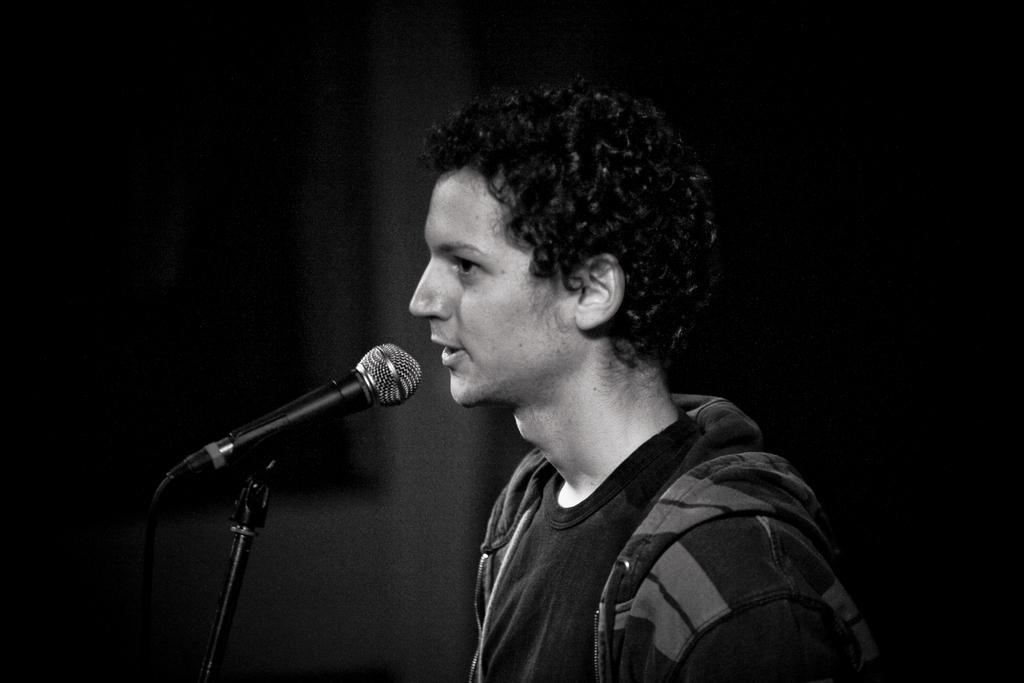Could you give a brief overview of what you see in this image? In this image we can see a man, mic, cable and a mic stand. 